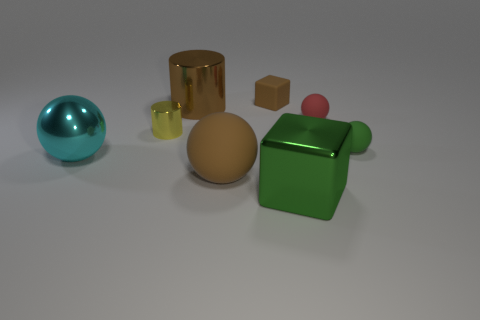There is a tiny block; is its color the same as the shiny cylinder that is behind the yellow metal thing?
Provide a succinct answer. Yes. What is the material of the brown object that is both left of the small brown object and behind the tiny red object?
Offer a very short reply. Metal. There is a object that is the same color as the big block; what size is it?
Offer a terse response. Small. Does the tiny thing that is behind the red matte sphere have the same shape as the big metal object that is behind the red matte sphere?
Keep it short and to the point. No. Is there a small yellow shiny thing?
Give a very brief answer. Yes. There is a metallic thing that is the same shape as the red rubber thing; what color is it?
Provide a short and direct response. Cyan. What is the color of the block that is the same size as the green ball?
Provide a short and direct response. Brown. Do the small green object and the yellow thing have the same material?
Ensure brevity in your answer.  No. How many metal cylinders are the same color as the tiny rubber cube?
Provide a succinct answer. 1. Do the small rubber block and the large shiny cylinder have the same color?
Provide a short and direct response. Yes. 